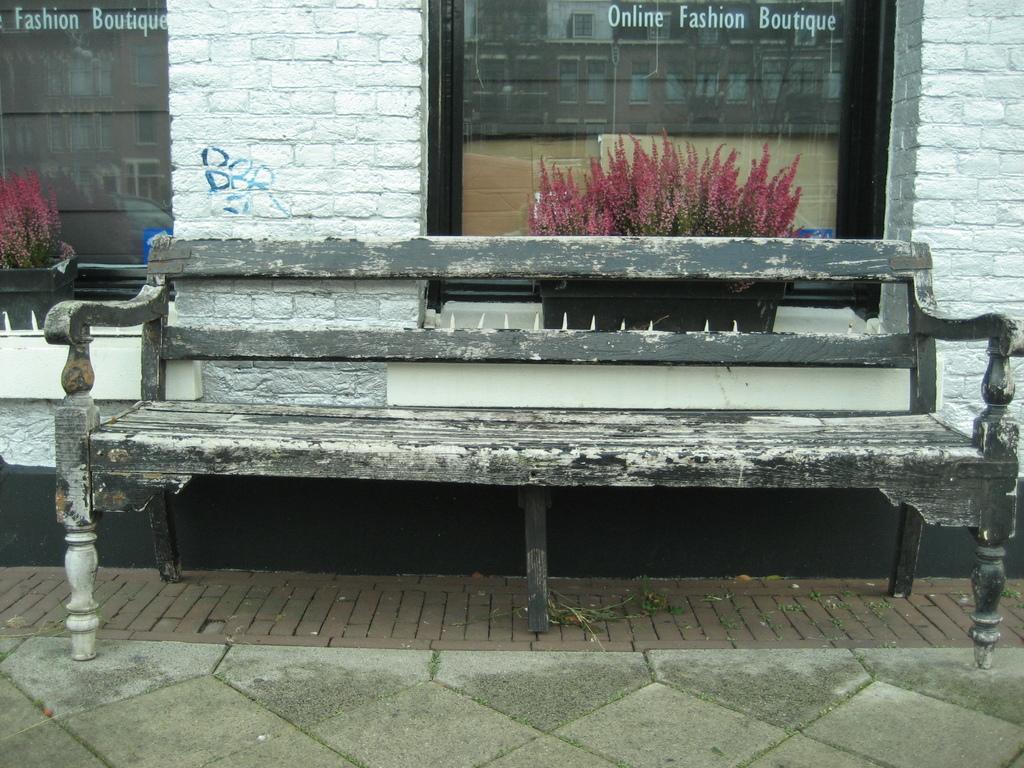In one or two sentences, can you explain what this image depicts? In front of the image there is a wooden bench, behind the bench there are flower pots on the glass windows with some text on it, beside the windows there are walls and there is some text on the wall, from the glass windows we can see the reflection of buildings and vehicles. 